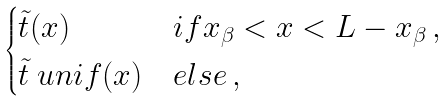Convert formula to latex. <formula><loc_0><loc_0><loc_500><loc_500>\begin{cases} \tilde { t } ( x ) & i f x _ { \beta } < x < L - x _ { \beta } \, , \\ \tilde { t } \ u n i f ( x ) & e l s e \, , \end{cases}</formula> 